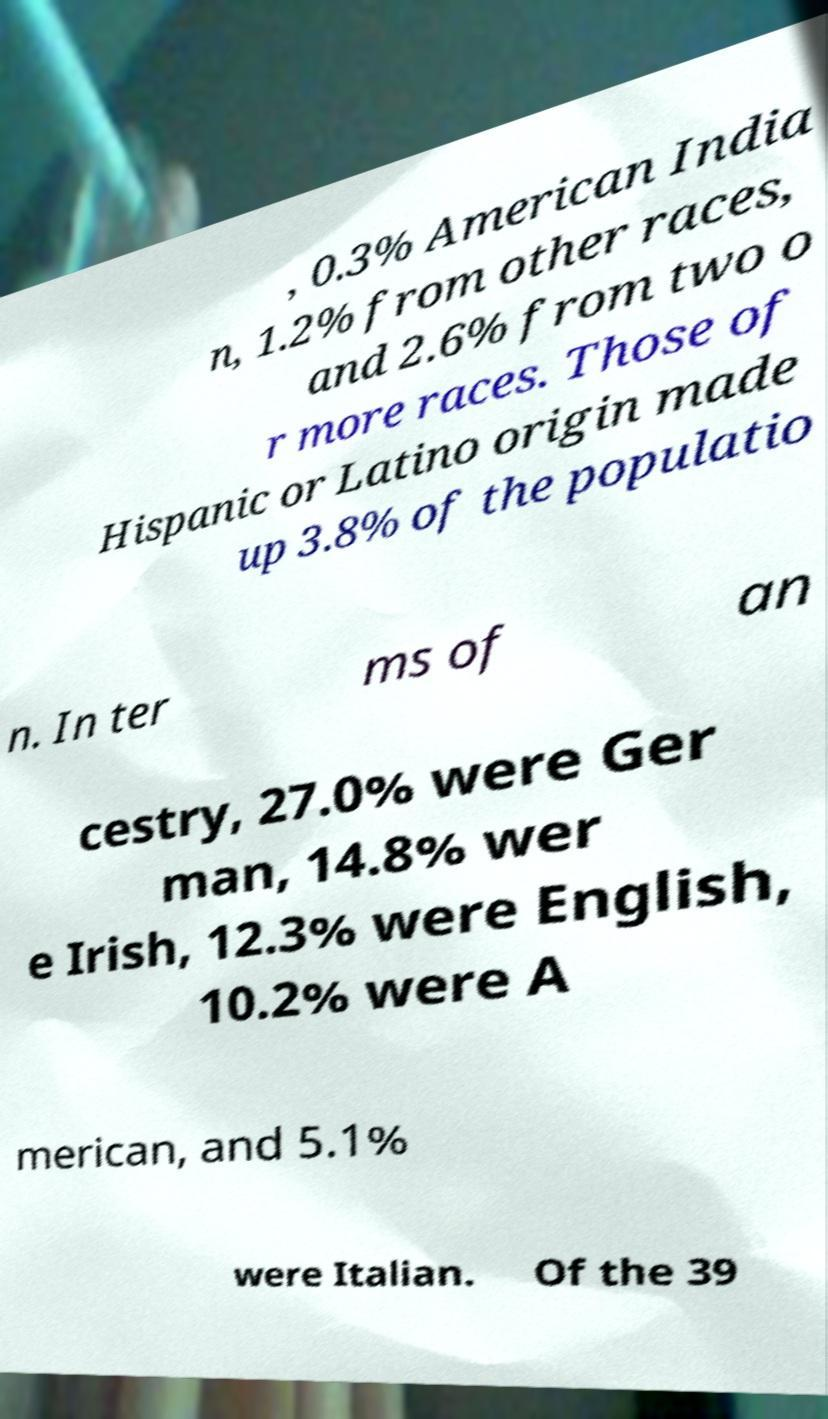What messages or text are displayed in this image? I need them in a readable, typed format. , 0.3% American India n, 1.2% from other races, and 2.6% from two o r more races. Those of Hispanic or Latino origin made up 3.8% of the populatio n. In ter ms of an cestry, 27.0% were Ger man, 14.8% wer e Irish, 12.3% were English, 10.2% were A merican, and 5.1% were Italian. Of the 39 